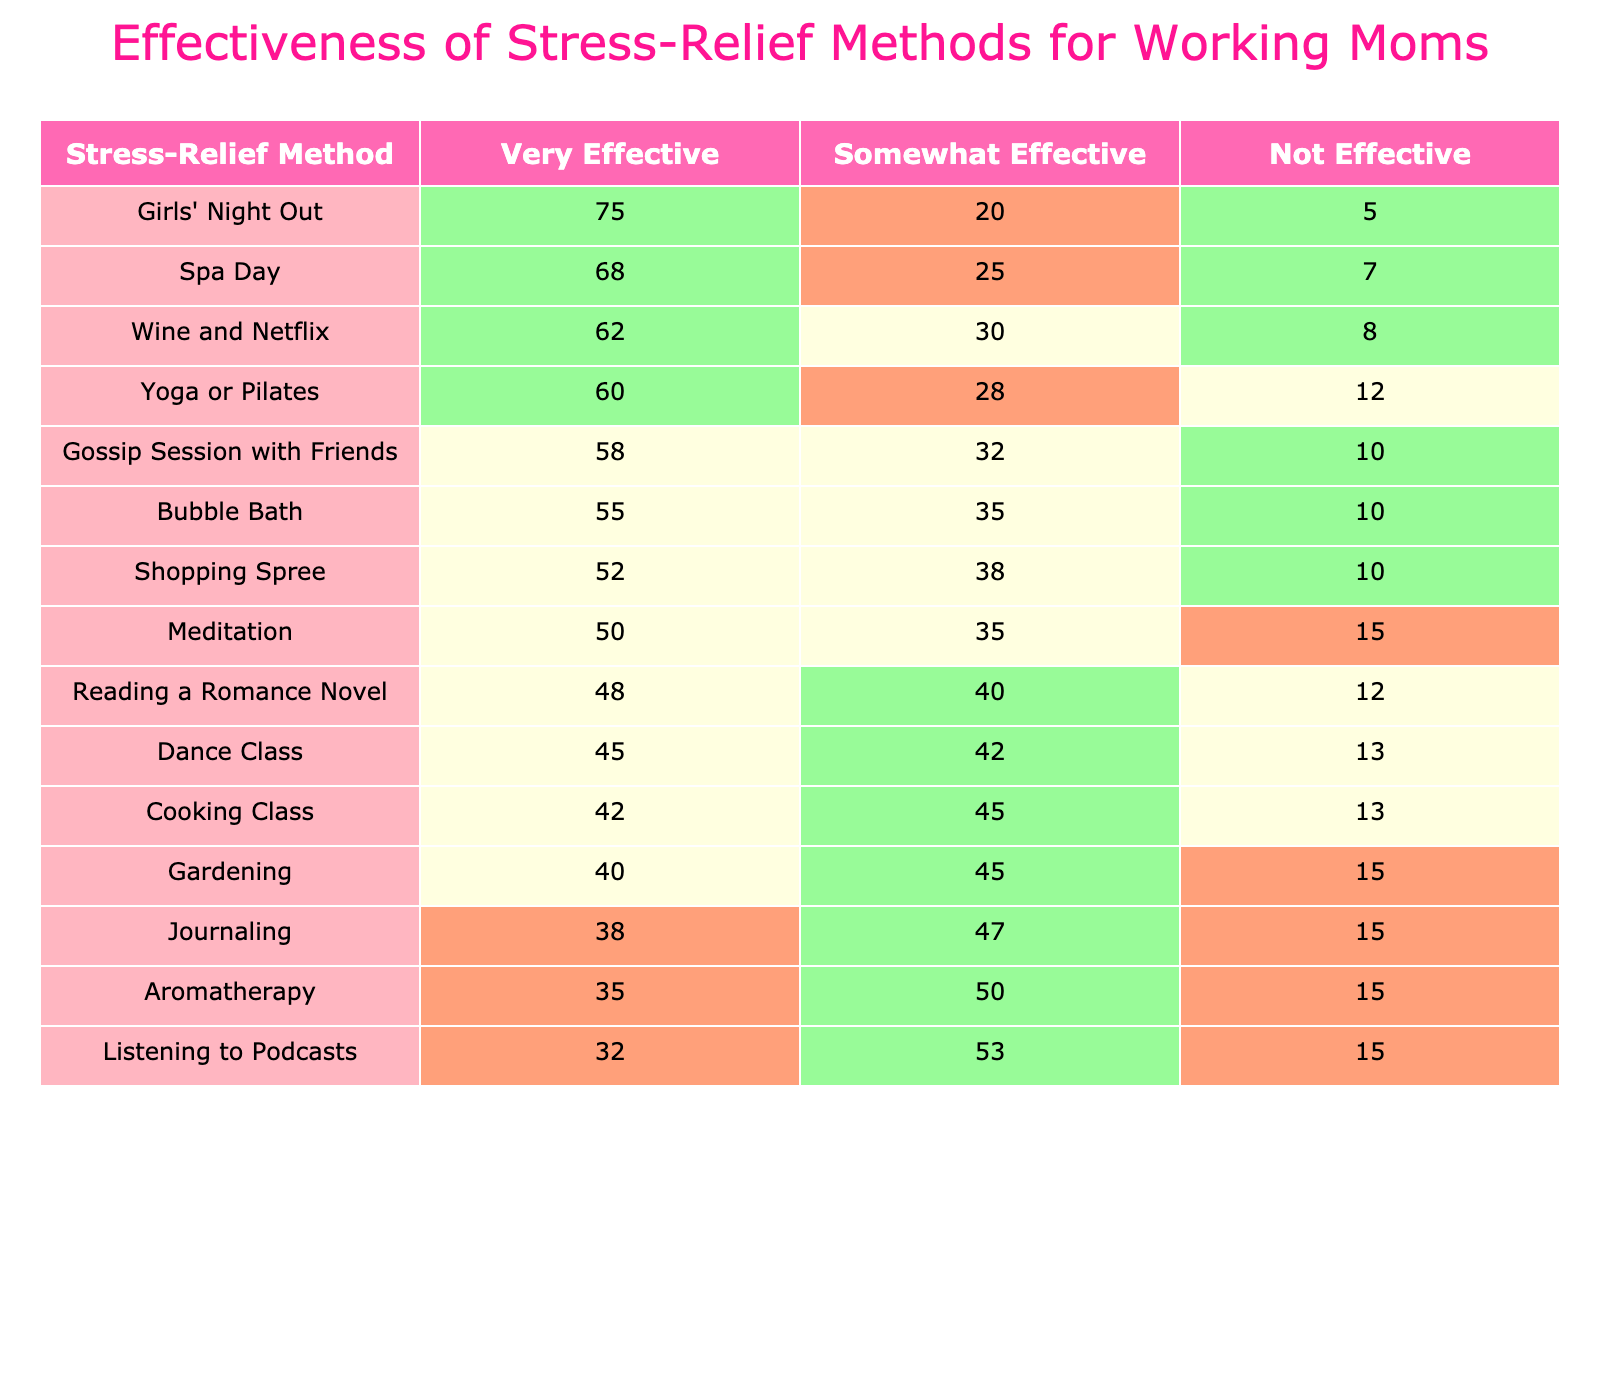What is the percentage of mothers who found "Girls' Night Out" to be very effective? According to the table, "Girls' Night Out" has a very effective rating of 75%.
Answer: 75% Which stress-relief method has the lowest percentage of mothers rating it as very effective? Checking the table, "Listening to Podcasts" has the lowest very effective rating at 32%.
Answer: Listening to Podcasts What is the percentage difference between those who found "Spa Day" and "Wine and Netflix" very effective? "Spa Day" is rated 68% very effective and "Wine and Netflix" is rated 62%. The difference is 68% - 62% = 6%.
Answer: 6% What is the average percentage of mothers rating "Yoga or Pilates", "Gossip Session with Friends", and "Bubble Bath" as very effective? The percentages for these methods are 60%, 58%, and 55%, respectively. The average is (60 + 58 + 55) / 3 = 57.67%, which can be rounded to 58%.
Answer: 58% Is it true that more than half of the mothers found "Meditation" to be at least somewhat effective? "Meditation" has a somewhat effective rating of 35% and not effective of 15%, meaning 50% rated it as either very or somewhat effective. Therefore, it is not true as half does not exceed.
Answer: No If a mother wants to choose a method with the highest effectiveness, what method should she select based on this table? The method with the highest percentage rating for very effective is "Girls' Night Out" at 75%.
Answer: Girls' Night Out What is the combined percentage of mothers rating "Shopping Spree" and "Gardening" as either very effective or somewhat effective? "Shopping Spree" has a very effective rating of 52% and somewhat effective of 38%. "Gardening" has 40% very effective and 45% somewhat effective. Combining these, (52 + 38 + 40 + 45) = 175%. Therefore, the combined percentage is 175%.
Answer: 175% Which method has the highest percentage of mothers rating it as not effective? "Listening to Podcasts" and "Aromatherapy" both have a not effective rating of 15%, which is the highest among all methods.
Answer: Listening to Podcasts and Aromatherapy What percentage of mothers found "Dance Class" to be not effective? Referring to the table, "Dance Class" has a not effective rating of 13%.
Answer: 13% Which method has the closest percentage ratings for "Somewhat Effective" and "Not Effective"? "Aromatherapy" has somewhat effective at 50% and not effective at 15%, giving it the smallest gap of 35%.
Answer: Aromatherapy 